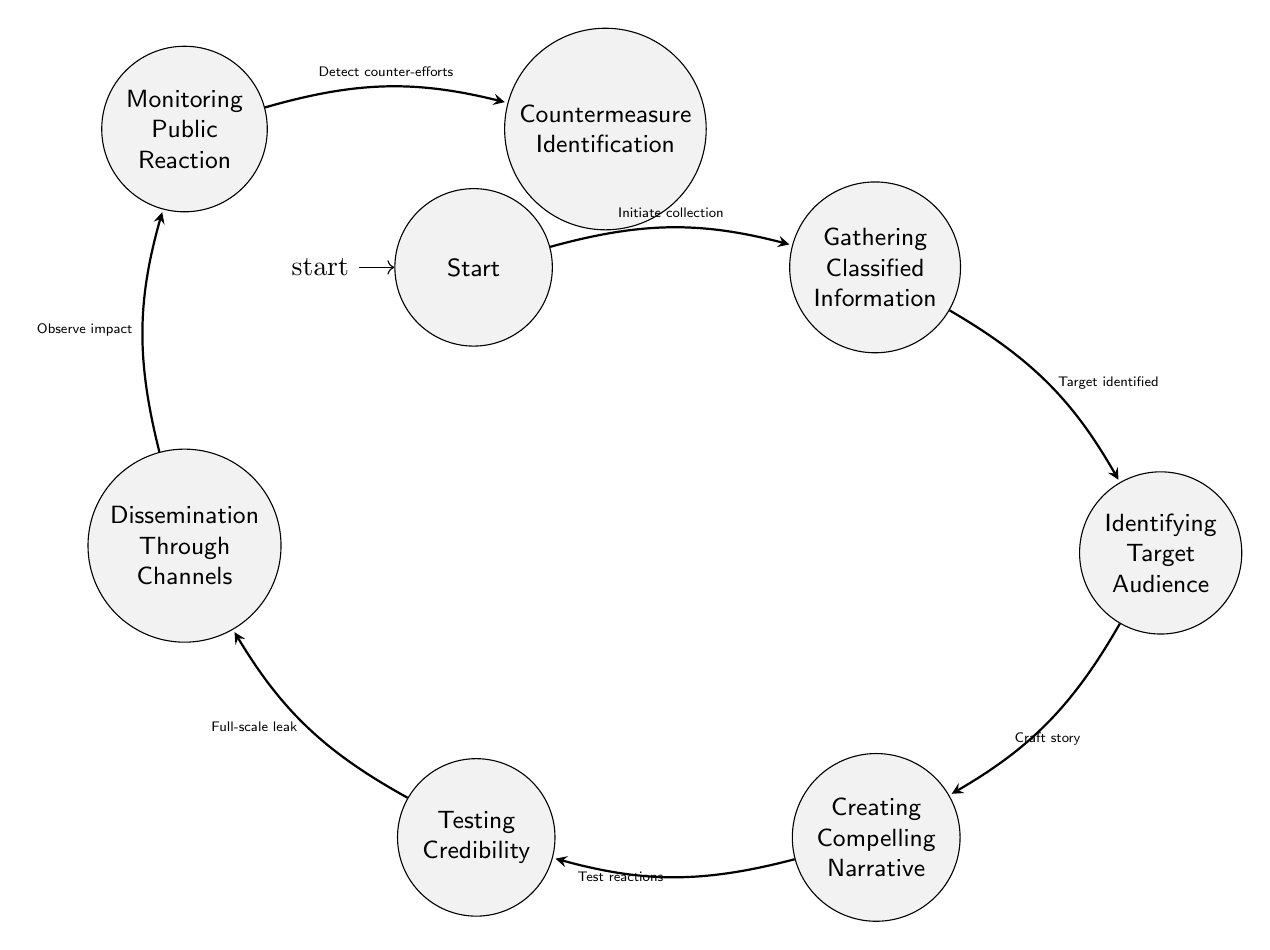What is the first state before any action is taken? The diagram begins at the state labeled "Start," which is explicitly described as the initial state before the leak begins, indicating no actions have occurred yet.
Answer: Start How many total states are present in the diagram? By counting the states listed in the diagram, there are seven distinct states depicted, which include Start, Gathering Classified Information, Identifying Target Audience, Creating Compelling Narrative, Testing Credibility, Dissemination Through Channels, Monitoring Public Reaction, and Countermeasure Identification.
Answer: 7 What action follows "Creating Compelling Narrative"? After the state of "Creating Compelling Narrative," the next transition in the diagram leads to the state "Testing Credibility," indicating that this is the subsequent action taken.
Answer: Testing Credibility What is the final state mentioned in the diagram? The last state depicted in the diagram is "Countermeasure Identification," which follows the earlier process and represents the concluding state of the flow described.
Answer: Countermeasure Identification What is the transition action that occurs from "Testing Credibility" to "Dissemination Through Channels"? The transition described in the diagram states that the action taken from "Testing Credibility" to "Dissemination Through Channels" is represented as a "Full-scale leak," indicating a significant step in the flow process.
Answer: Full-scale leak Which state involves monitoring the spread and reception of leaked information? The state that specifically includes the task of observing how the leaked information is spreading and being received is called "Monitoring Public Reaction," as highlighted in the diagram.
Answer: Monitoring Public Reaction What is the first action in the flow of states? The first action that is indicated in the transition from the initial state is "Initiate collection," where the process starts by gathering relevant data.
Answer: Initiate collection What state immediately follows "Identifying Target Audience"? The state that immediately follows "Identifying Target Audience" in the flow of the diagram is "Creating Compelling Narrative," marking the next step in the process.
Answer: Creating Compelling Narrative 